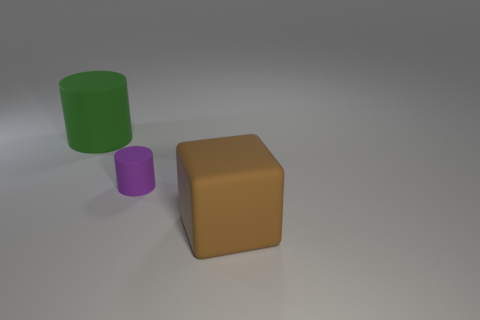Is the color of the large matte block the same as the tiny thing?
Your answer should be compact. No. The large brown thing is what shape?
Provide a succinct answer. Cube. What number of gray things are the same material as the large green cylinder?
Give a very brief answer. 0. There is a large thing that is the same material as the large cube; what color is it?
Give a very brief answer. Green. Does the green object have the same size as the block that is on the right side of the tiny purple thing?
Give a very brief answer. Yes. What is the cylinder to the right of the large matte object on the left side of the block to the right of the big cylinder made of?
Offer a terse response. Rubber. What number of things are either big yellow blocks or small purple rubber objects?
Make the answer very short. 1. There is a large object that is on the left side of the brown rubber object; is it the same color as the cylinder that is right of the big green rubber object?
Make the answer very short. No. The object that is the same size as the green cylinder is what shape?
Make the answer very short. Cube. How many objects are big things that are in front of the green rubber cylinder or large rubber things behind the brown rubber thing?
Your answer should be very brief. 2. 